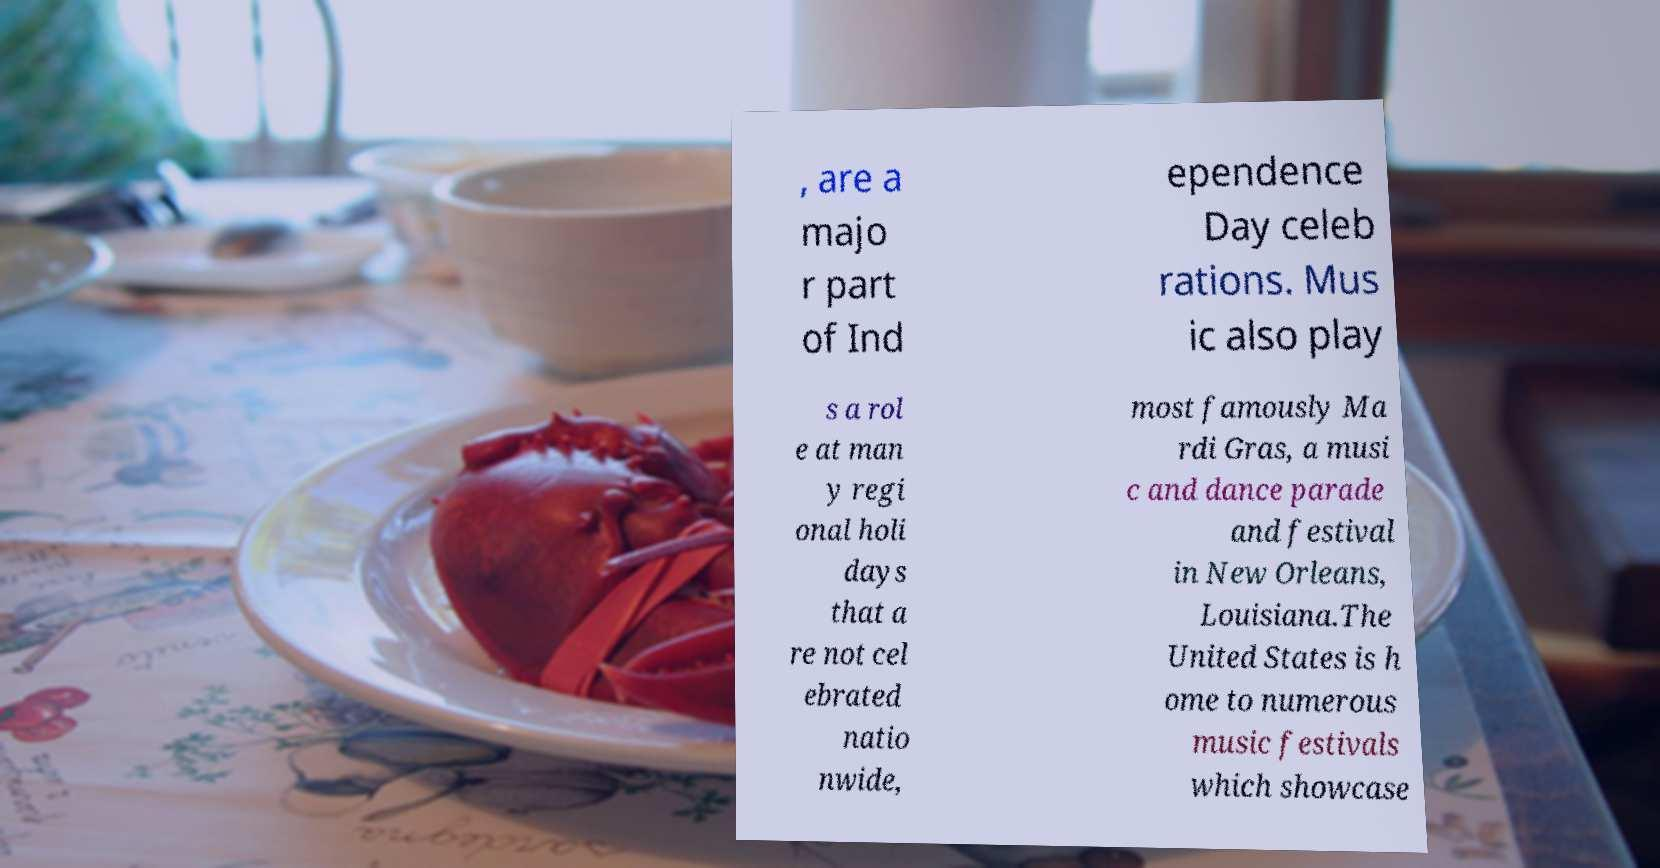What messages or text are displayed in this image? I need them in a readable, typed format. , are a majo r part of Ind ependence Day celeb rations. Mus ic also play s a rol e at man y regi onal holi days that a re not cel ebrated natio nwide, most famously Ma rdi Gras, a musi c and dance parade and festival in New Orleans, Louisiana.The United States is h ome to numerous music festivals which showcase 